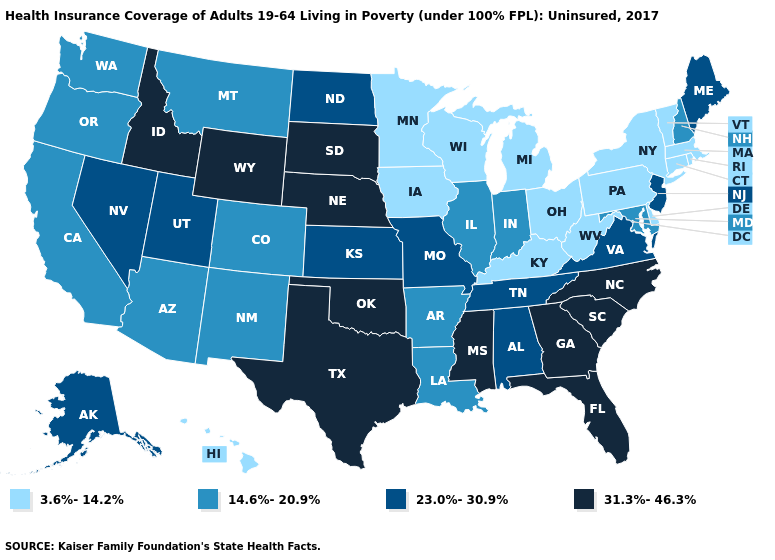Is the legend a continuous bar?
Short answer required. No. Among the states that border Virginia , does Tennessee have the lowest value?
Short answer required. No. What is the value of Ohio?
Be succinct. 3.6%-14.2%. Among the states that border Oregon , does Washington have the lowest value?
Be succinct. Yes. What is the value of Utah?
Keep it brief. 23.0%-30.9%. Does Vermont have the lowest value in the Northeast?
Answer briefly. Yes. What is the value of Illinois?
Answer briefly. 14.6%-20.9%. Does Arizona have the highest value in the USA?
Be succinct. No. Which states hav the highest value in the MidWest?
Be succinct. Nebraska, South Dakota. What is the value of Hawaii?
Short answer required. 3.6%-14.2%. Among the states that border Georgia , does Florida have the lowest value?
Concise answer only. No. Name the states that have a value in the range 31.3%-46.3%?
Be succinct. Florida, Georgia, Idaho, Mississippi, Nebraska, North Carolina, Oklahoma, South Carolina, South Dakota, Texas, Wyoming. What is the value of Florida?
Short answer required. 31.3%-46.3%. What is the lowest value in the USA?
Quick response, please. 3.6%-14.2%. Which states hav the highest value in the MidWest?
Give a very brief answer. Nebraska, South Dakota. 